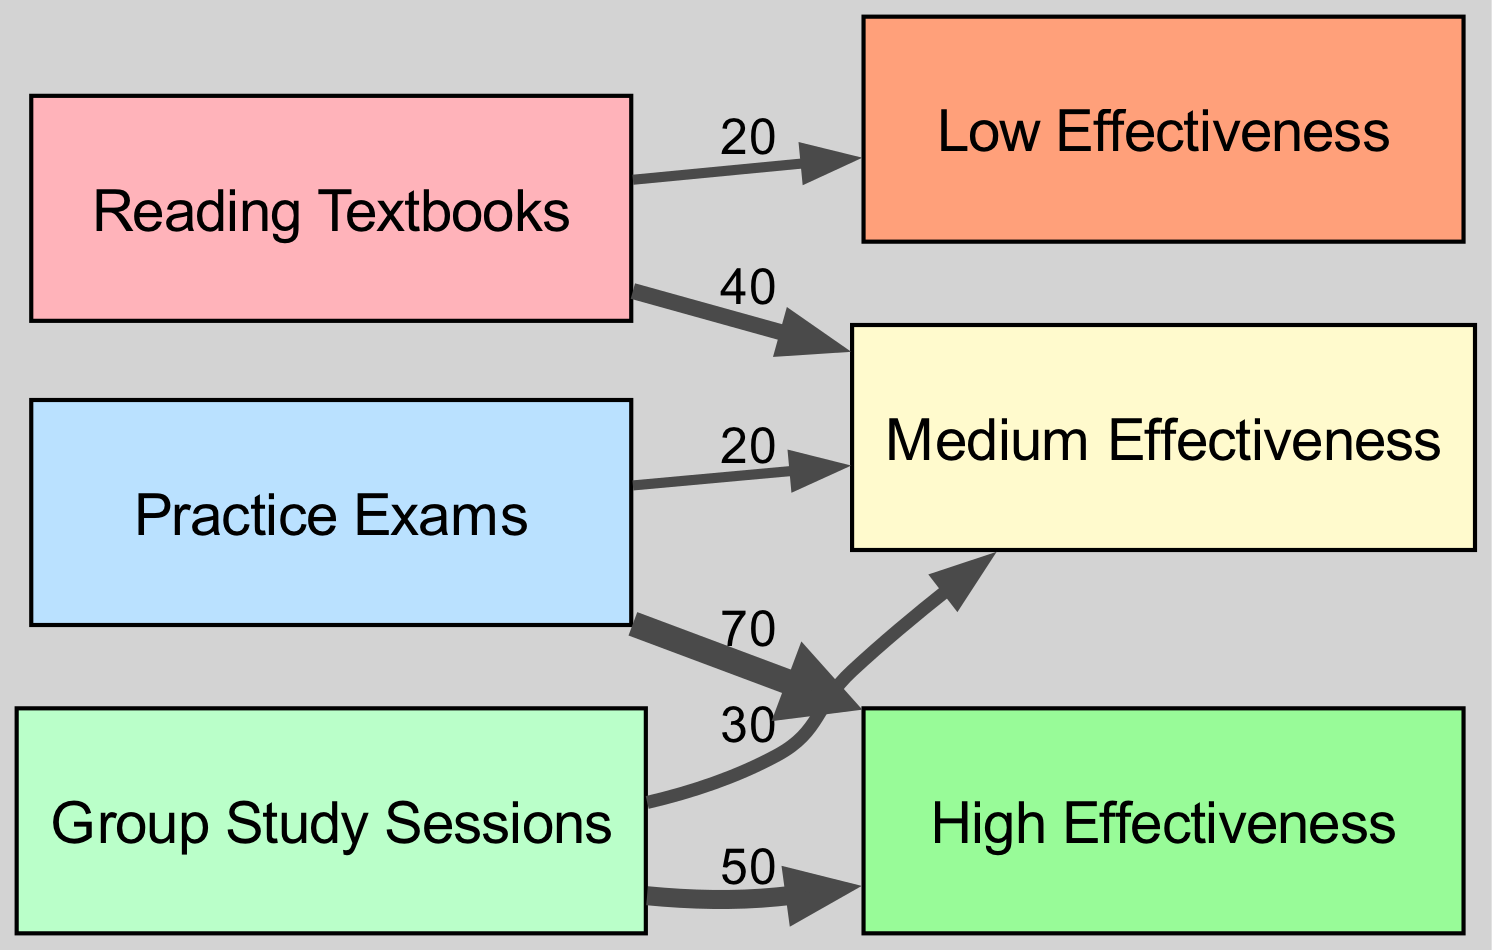What is the total number of nodes in the diagram? The diagram includes six distinct nodes: three study methods (Reading, Group Study, Practice Exams) and three effectiveness levels (High Effectiveness, Medium Effectiveness, Low Effectiveness). Therefore, the total number of nodes is six.
Answer: 6 Which study method has the highest effectiveness rating? By examining the outgoing links from each study method, Practice Exams links to High Effectiveness with a value of 70, which is the highest compared to the other study methods.
Answer: Practice Exams What is the value of the link from Group Study to Medium Effectiveness? Looking at the links from Group Study, there is a direct link to Medium Effectiveness with a value of 30, identified clearly in the diagram.
Answer: 30 What percentage of the effectiveness for Reading is Low? The total effectiveness for Reading can be calculated by adding its links: Medium (40) and Low (20), giving 60 overall. The Low effectiveness link has a value of 20, making the percentage (20/60)*100 = 33.33%.
Answer: 33.33% What method is associated with the lowest effectiveness value? From the links, Reading has a Low Effectiveness value of 20, which is the lowest effectiveness value among the studied methods in the diagram.
Answer: Reading Comparing the effectiveness from Group Study and Practice Exams, what is the total value of the High effectiveness? Group Study has a High Effectiveness value of 50, and Practice Exams has a High Effectiveness value of 70. Adding these two gives a total of 120 for High Effectiveness.
Answer: 120 Which effectiveness level has more total value from all study methods combined? By summing up the values for Medium Effectiveness, we have Reading (40) + Group Study (30) + Practice Exams (20) = 90. For Low Effectiveness, it’s only Reading with 20. Thus, Medium Effectiveness has the greater total value.
Answer: Medium Effectiveness What is the value of the link from Practice Exams to Medium Effectiveness compared to Reading? The link from Practice Exams to Medium Effectiveness has a value of 20, while the value from Reading to Medium Effectiveness is 40. Therefore, Reading has a higher value in this case.
Answer: 20 